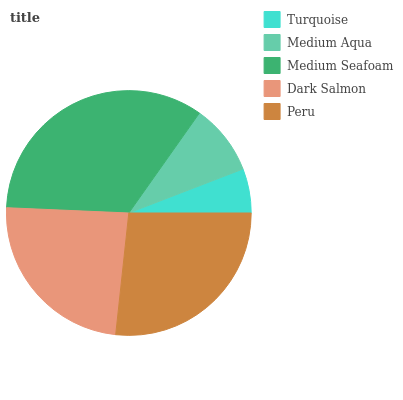Is Turquoise the minimum?
Answer yes or no. Yes. Is Medium Seafoam the maximum?
Answer yes or no. Yes. Is Medium Aqua the minimum?
Answer yes or no. No. Is Medium Aqua the maximum?
Answer yes or no. No. Is Medium Aqua greater than Turquoise?
Answer yes or no. Yes. Is Turquoise less than Medium Aqua?
Answer yes or no. Yes. Is Turquoise greater than Medium Aqua?
Answer yes or no. No. Is Medium Aqua less than Turquoise?
Answer yes or no. No. Is Dark Salmon the high median?
Answer yes or no. Yes. Is Dark Salmon the low median?
Answer yes or no. Yes. Is Medium Aqua the high median?
Answer yes or no. No. Is Medium Seafoam the low median?
Answer yes or no. No. 